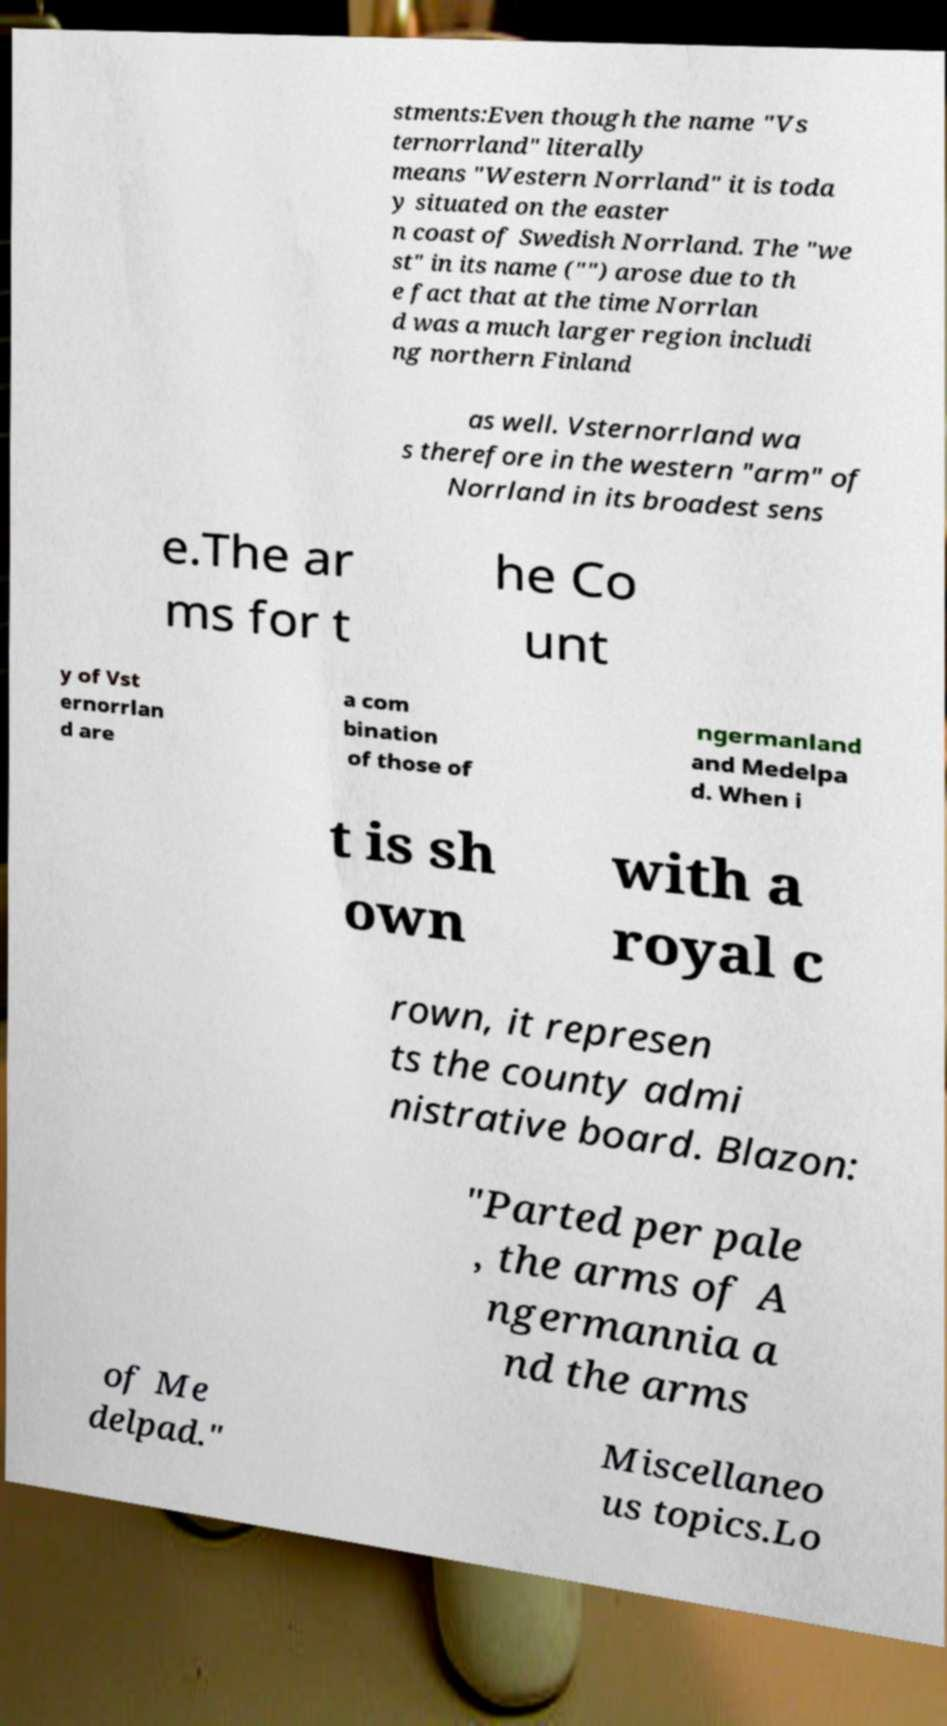Could you assist in decoding the text presented in this image and type it out clearly? stments:Even though the name "Vs ternorrland" literally means "Western Norrland" it is toda y situated on the easter n coast of Swedish Norrland. The "we st" in its name ("") arose due to th e fact that at the time Norrlan d was a much larger region includi ng northern Finland as well. Vsternorrland wa s therefore in the western "arm" of Norrland in its broadest sens e.The ar ms for t he Co unt y of Vst ernorrlan d are a com bination of those of ngermanland and Medelpa d. When i t is sh own with a royal c rown, it represen ts the county admi nistrative board. Blazon: "Parted per pale , the arms of A ngermannia a nd the arms of Me delpad." Miscellaneo us topics.Lo 